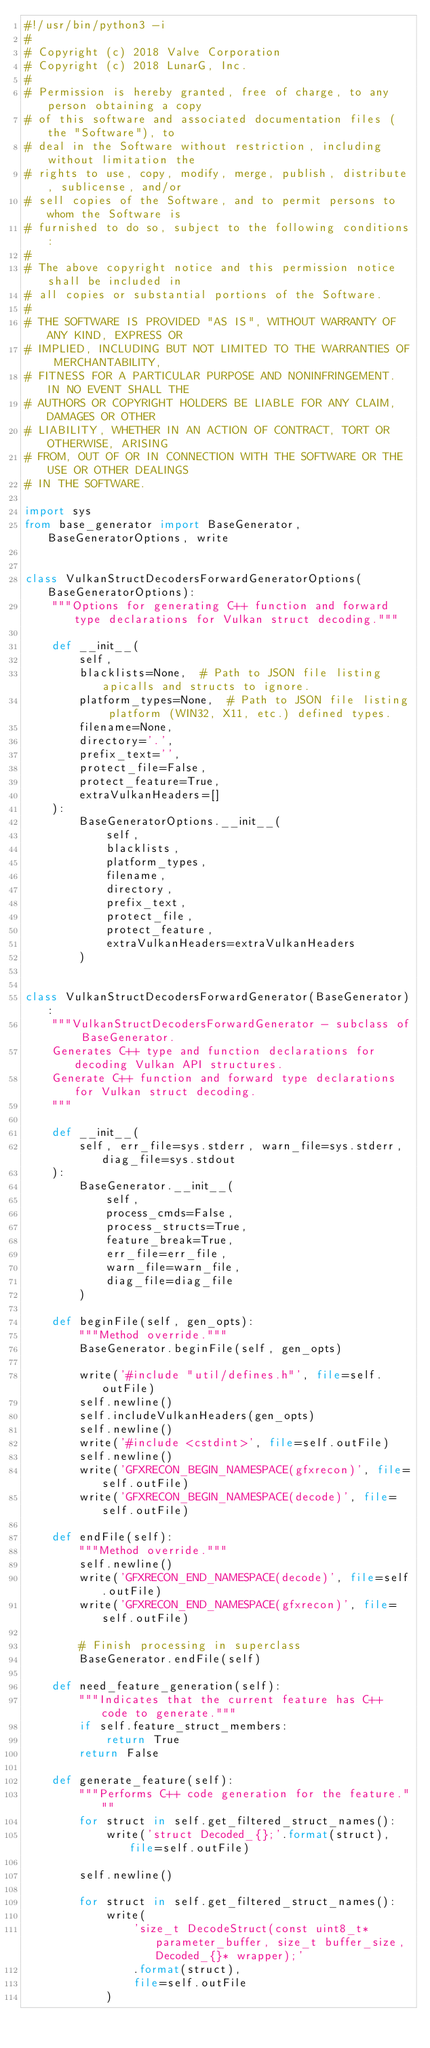Convert code to text. <code><loc_0><loc_0><loc_500><loc_500><_Python_>#!/usr/bin/python3 -i
#
# Copyright (c) 2018 Valve Corporation
# Copyright (c) 2018 LunarG, Inc.
#
# Permission is hereby granted, free of charge, to any person obtaining a copy
# of this software and associated documentation files (the "Software"), to
# deal in the Software without restriction, including without limitation the
# rights to use, copy, modify, merge, publish, distribute, sublicense, and/or
# sell copies of the Software, and to permit persons to whom the Software is
# furnished to do so, subject to the following conditions:
#
# The above copyright notice and this permission notice shall be included in
# all copies or substantial portions of the Software.
#
# THE SOFTWARE IS PROVIDED "AS IS", WITHOUT WARRANTY OF ANY KIND, EXPRESS OR
# IMPLIED, INCLUDING BUT NOT LIMITED TO THE WARRANTIES OF MERCHANTABILITY,
# FITNESS FOR A PARTICULAR PURPOSE AND NONINFRINGEMENT. IN NO EVENT SHALL THE
# AUTHORS OR COPYRIGHT HOLDERS BE LIABLE FOR ANY CLAIM, DAMAGES OR OTHER
# LIABILITY, WHETHER IN AN ACTION OF CONTRACT, TORT OR OTHERWISE, ARISING
# FROM, OUT OF OR IN CONNECTION WITH THE SOFTWARE OR THE USE OR OTHER DEALINGS
# IN THE SOFTWARE.

import sys
from base_generator import BaseGenerator, BaseGeneratorOptions, write


class VulkanStructDecodersForwardGeneratorOptions(BaseGeneratorOptions):
    """Options for generating C++ function and forward type declarations for Vulkan struct decoding."""

    def __init__(
        self,
        blacklists=None,  # Path to JSON file listing apicalls and structs to ignore.
        platform_types=None,  # Path to JSON file listing platform (WIN32, X11, etc.) defined types.
        filename=None,
        directory='.',
        prefix_text='',
        protect_file=False,
        protect_feature=True,
        extraVulkanHeaders=[]
    ):
        BaseGeneratorOptions.__init__(
            self,
            blacklists,
            platform_types,
            filename,
            directory,
            prefix_text,
            protect_file,
            protect_feature,
            extraVulkanHeaders=extraVulkanHeaders
        )


class VulkanStructDecodersForwardGenerator(BaseGenerator):
    """VulkanStructDecodersForwardGenerator - subclass of BaseGenerator.
    Generates C++ type and function declarations for decoding Vulkan API structures.
    Generate C++ function and forward type declarations for Vulkan struct decoding.
    """

    def __init__(
        self, err_file=sys.stderr, warn_file=sys.stderr, diag_file=sys.stdout
    ):
        BaseGenerator.__init__(
            self,
            process_cmds=False,
            process_structs=True,
            feature_break=True,
            err_file=err_file,
            warn_file=warn_file,
            diag_file=diag_file
        )

    def beginFile(self, gen_opts):
        """Method override."""
        BaseGenerator.beginFile(self, gen_opts)

        write('#include "util/defines.h"', file=self.outFile)
        self.newline()
        self.includeVulkanHeaders(gen_opts)
        self.newline()
        write('#include <cstdint>', file=self.outFile)
        self.newline()
        write('GFXRECON_BEGIN_NAMESPACE(gfxrecon)', file=self.outFile)
        write('GFXRECON_BEGIN_NAMESPACE(decode)', file=self.outFile)

    def endFile(self):
        """Method override."""
        self.newline()
        write('GFXRECON_END_NAMESPACE(decode)', file=self.outFile)
        write('GFXRECON_END_NAMESPACE(gfxrecon)', file=self.outFile)

        # Finish processing in superclass
        BaseGenerator.endFile(self)

    def need_feature_generation(self):
        """Indicates that the current feature has C++ code to generate."""
        if self.feature_struct_members:
            return True
        return False

    def generate_feature(self):
        """Performs C++ code generation for the feature."""
        for struct in self.get_filtered_struct_names():
            write('struct Decoded_{};'.format(struct), file=self.outFile)

        self.newline()

        for struct in self.get_filtered_struct_names():
            write(
                'size_t DecodeStruct(const uint8_t* parameter_buffer, size_t buffer_size, Decoded_{}* wrapper);'
                .format(struct),
                file=self.outFile
            )
</code> 